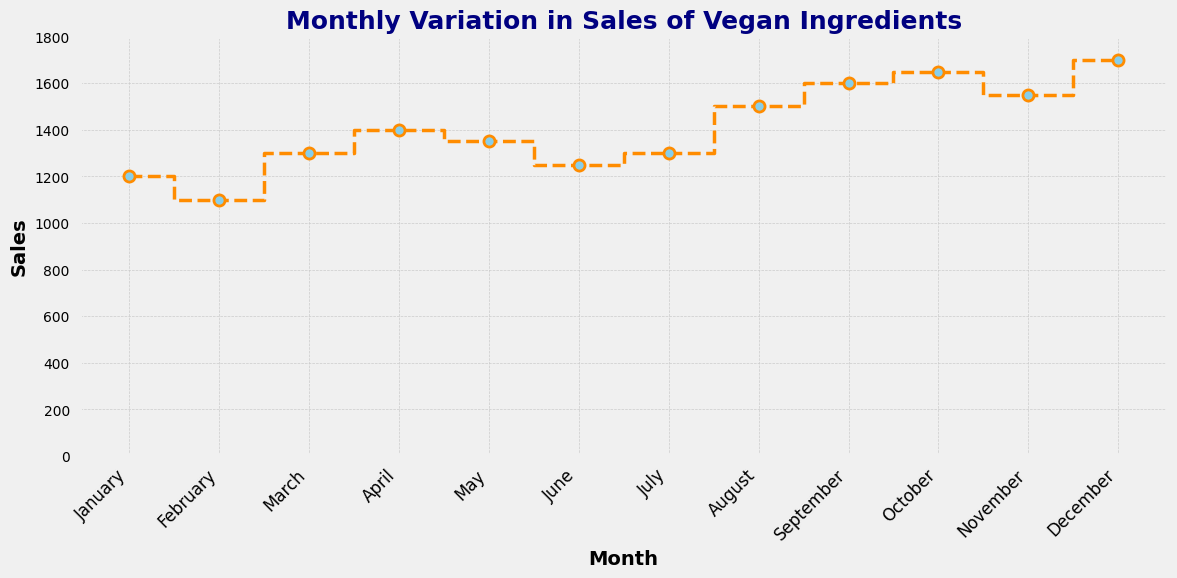What month has the highest sales? Look at the y-axis and the step plot. The highest sales point occurs in December with a value of 1700.
Answer: December Which month shows the lowest sales figure? From the step plot, the lowest sales point is in February with a value of 1100.
Answer: February How much do sales increase from February to March? Sales in February are 1100 and in March are 1300. The increase is 1300 - 1100 = 200.
Answer: 200 What is the average sales figure from January to June? Add the sales figures from January to June: 1200 + 1100 + 1300 + 1400 + 1350 + 1250 = 7600. There are 6 months, so the average is 7600 / 6.
Answer: 1266.67 From which month to which month does the largest increase in sales occur? And what is the value of that increase? The biggest increase is from November to December, from 1550 to 1700, an increase of 1700 - 1550 = 150.
Answer: November to December, 150 What is the month with the median sales figure? List the sales in ascending order: 1100, 1200, 1250, 1300, 1300, 1350, 1400, 1500, 1550, 1600, 1650, 1700. The median figures fall between the 6th and 7th months (June and July), which are 1250 and 1300, so the median month is July.
Answer: July What is the total sales from August to December? Add the sales figures from August to December: 1500 + 1600 + 1650 + 1550 + 1700 = 8000.
Answer: 8000 In which months do sales exceed 1500? From the chart, sales exceed 1500 in August (1500), September (1600), October (1650), November (1550), and December (1700).
Answer: August, September, October, November, December How does the trend in sales from July to October compare to that from November to December? From July to October, sales increase from 1300 to 1650, while from November to December, sales increase from 1550 to 1700, which indicates a steady growth in both periods. However, July to October shows a longer gradual increase, whereas November to December shows a sharper increment in a shorter period.
Answer: Steady growth in both periods, sharper increase in November-December What is the range of sales figures throughout the year? The range is calculated by the difference between the maximum and minimum values: 1700 (December) - 1100 (February) = 600.
Answer: 600 